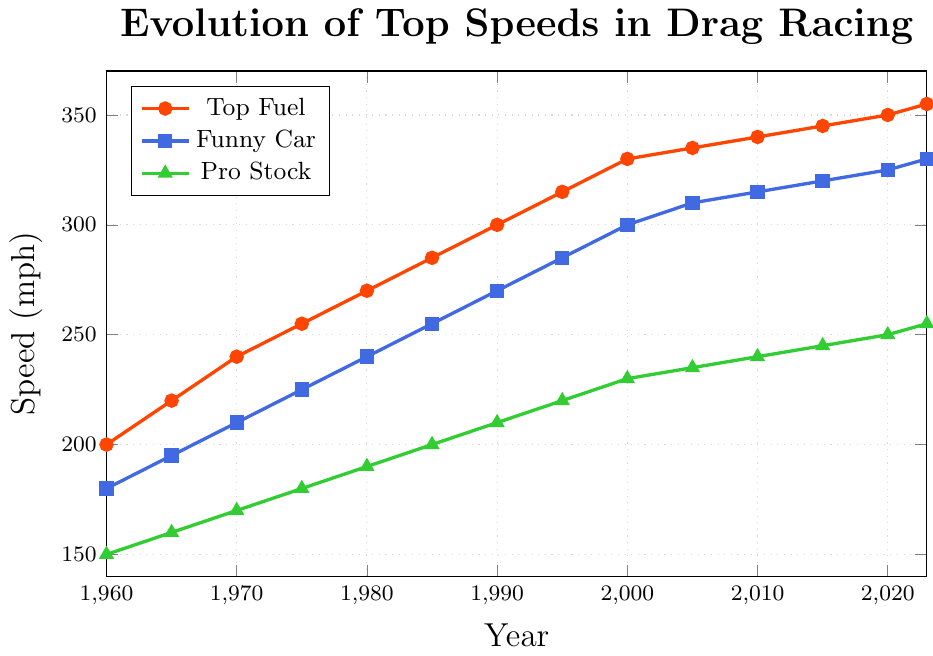What's the top speed for Top Fuel in 1995? Locate the Top Fuel line (red) on the line chart and find the speed value at the year 1995. The value is 315 mph.
Answer: 315 mph How much did the top speed for Funny Car increase from 1980 to 2000? Find the speed for Funny Car (blue line) in 1980 and 2000. Subtract the 1980 value (240 mph) from the 2000 value (300 mph). The increase is 60 mph.
Answer: 60 mph Which category had the smallest increase in top speed from 1960 to 2023? Calculate the increase for each category by subtracting the 1960 value from the 2023 value: Top Fuel: 355-200=155 mph, Funny Car: 330-180=150 mph, Pro Stock: 255-150=105 mph. The smallest increase is for Pro Stock.
Answer: Pro Stock In which decade did Pro Stock see the greatest increase in top speed? Find the differences in Pro Stock speeds (green line) for each decade: 
1960-1970: 170-150=20 mph 
1970-1980: 190-170=20 mph
1980-1990: 210-190=20 mph 
1990-2000: 230-210=20 mph 
2000-2010: 240-230=10 mph 
2010-2020: 250-240=10 mph.
The greatest rise is consistent at 20 mph for the decades 1960-1970, 1970-1980, 1980-1990, and 1990-2000.
Answer: 1960-2000 Which category consistently had the highest top speed since 1960? Identify the line that remains the highest on the chart from 1960 to 2023, which is the Top Fuel line (red).
Answer: Top Fuel By how many mph did the top speed for Top Fuel exceed Funny Car in 2023? Locate the Top Fuel and Funny Car values for 2023: Top Fuel is 355 mph, Funny Car is 330 mph. Subtract the Funny Car value from the Top Fuel value. The difference is 25 mph.
Answer: 25 mph What was the average top speed for Pro Stock in the decade 2010-2020? Locate and sum the Pro Stock speeds (green line) for 2010, 2015, and 2020: 2010=240 mph, 2015=245 mph, 2020=250 mph. The total is 240+245+250=735 mph. There are 3 data points, so the average is 735/3 = 245 mph.
Answer: 245 mph When comparing the three categories, which showed the most significant improvement in top speed from 2000 to 2020? Calculate the increase for each from 2000 to 2020: 
Top Fuel: 350-330=20 mph 
Funny Car: 325-300=25 mph 
Pro Stock: 250-230=20 mph.
The most significant improvement is in Funny Car.
Answer: Funny Car Which year saw the introduction of speed for Funny Car exceeding 300 mph? Find the first year where the Funny Car speed (blue line) surpasses 300 mph. This occurs in the year 2000.
Answer: 2000 